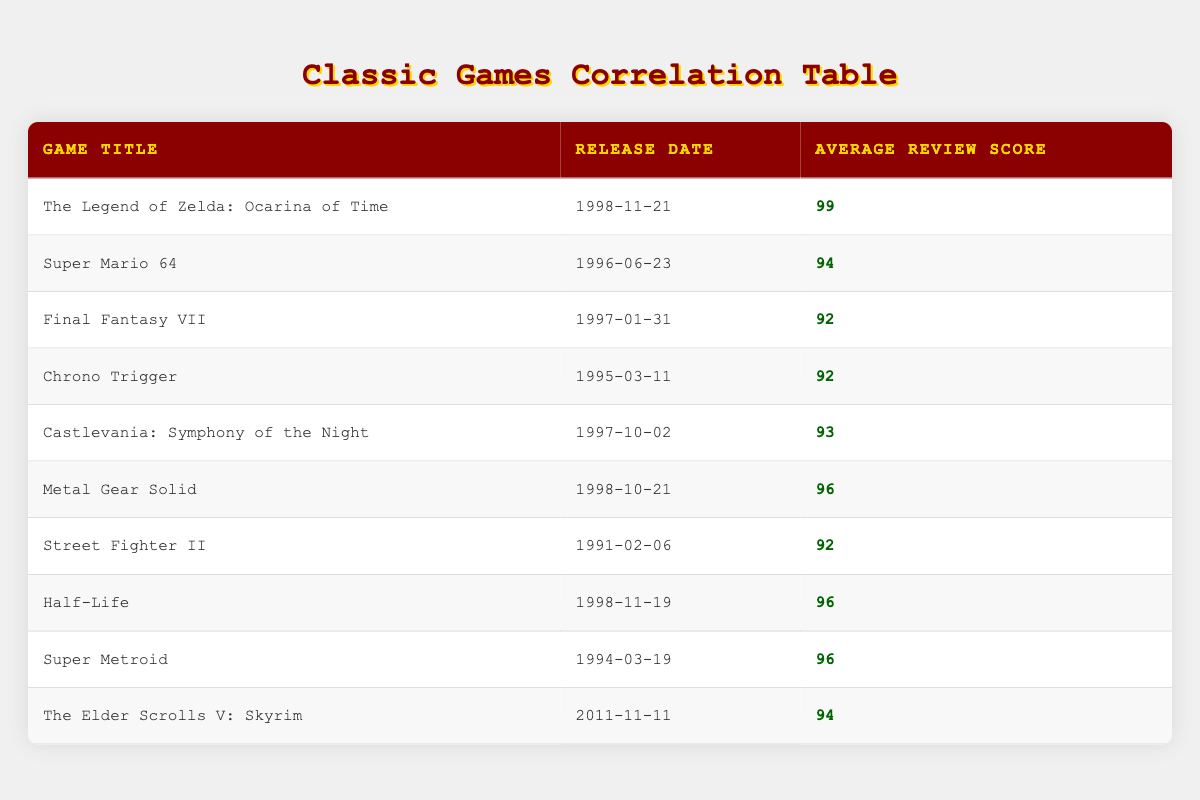What is the release date of "The Legend of Zelda: Ocarina of Time"? The release date is specified in the table for each game. Referring to the row for "The Legend of Zelda: Ocarina of Time," the release date is listed as 1998-11-21.
Answer: 1998-11-21 Which game has the highest average review score? The table provides average review scores for all games. By comparing the scores, "The Legend of Zelda: Ocarina of Time" has the highest score of 99, which is greater than all other game scores listed.
Answer: The Legend of Zelda: Ocarina of Time What is the average review score of games released before the year 1998? Calculate the average score for games released before 1998. The scores of these games are 92, 94, 92, 92, 96, and 96. Adding these scores gives 92 + 94 + 92 + 92 + 96 + 96 = 562. There are six games, so the average is 562 / 6 = approximately 93.67.
Answer: 93.67 Did "Half-Life" receive a higher score than "Street Fighter II"? The average review score for "Half-Life" is 96, while "Street Fighter II" has a score of 92. Comparing these two, 96 is greater than 92, so the statement is true.
Answer: Yes What is the difference between the highest and lowest average review scores in the table? Identify the highest score from the table, which is 99 from "The Legend of Zelda: Ocarina of Time," and the lowest score, which is 92 (multiple games share this score). The difference is calculated as 99 - 92 = 7.
Answer: 7 How many games have an average review score of 96 or higher? Count the games with scores of 96 and above. These are "The Legend of Zelda: Ocarina of Time" (99), "Half-Life" (96), "Metal Gear Solid" (96), and "Super Metroid" (96). There are four games that meet this criterion.
Answer: 4 Is "The Elder Scrolls V: Skyrim" the most recently released game in the table? The release date of "The Elder Scrolls V: Skyrim" is 2011-11-11, while the latest release date among the other games is 1998-11-21. Since 2011 is later than 1998, "Skyrim" is indeed the most recent game.
Answer: Yes Which game was released closest to the year 1997 based on the table? To determine this, we compare the release dates of the games around 1997. The games closest to 1997 are "Final Fantasy VII" (1997-01-31) and "Castlevania: Symphony of the Night" (1997-10-02). Both are in the same year, but "Final Fantasy VII" is the earliest.
Answer: Final Fantasy VII 